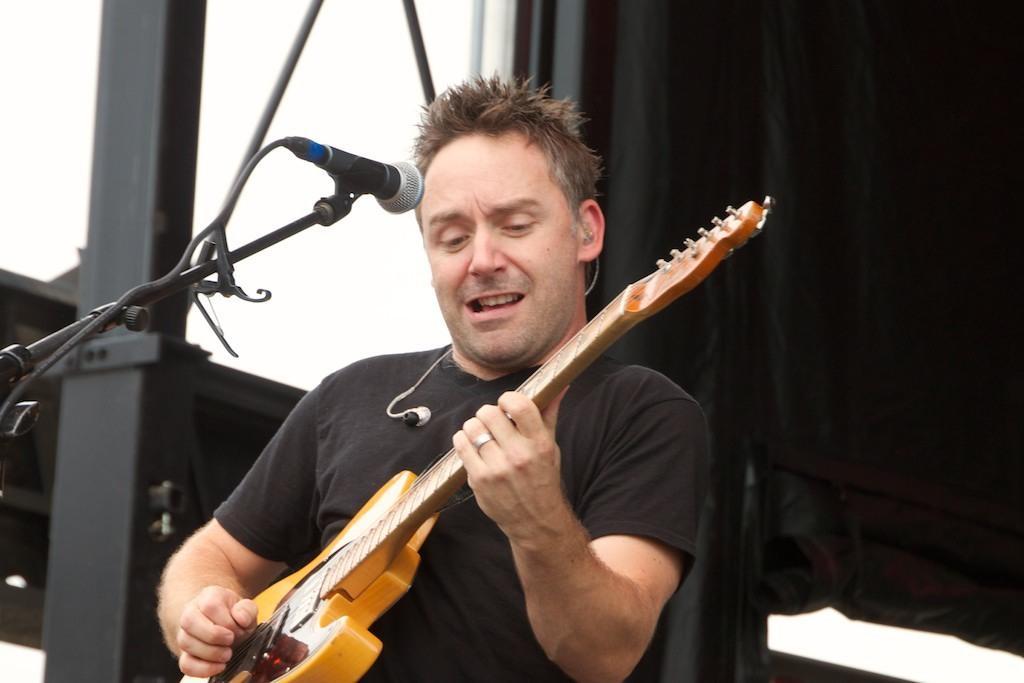Describe this image in one or two sentences. The image is outside of the room. In the image there is a man holding a guitar and playing it in front of a microphone. In background we can see black color curtain. 